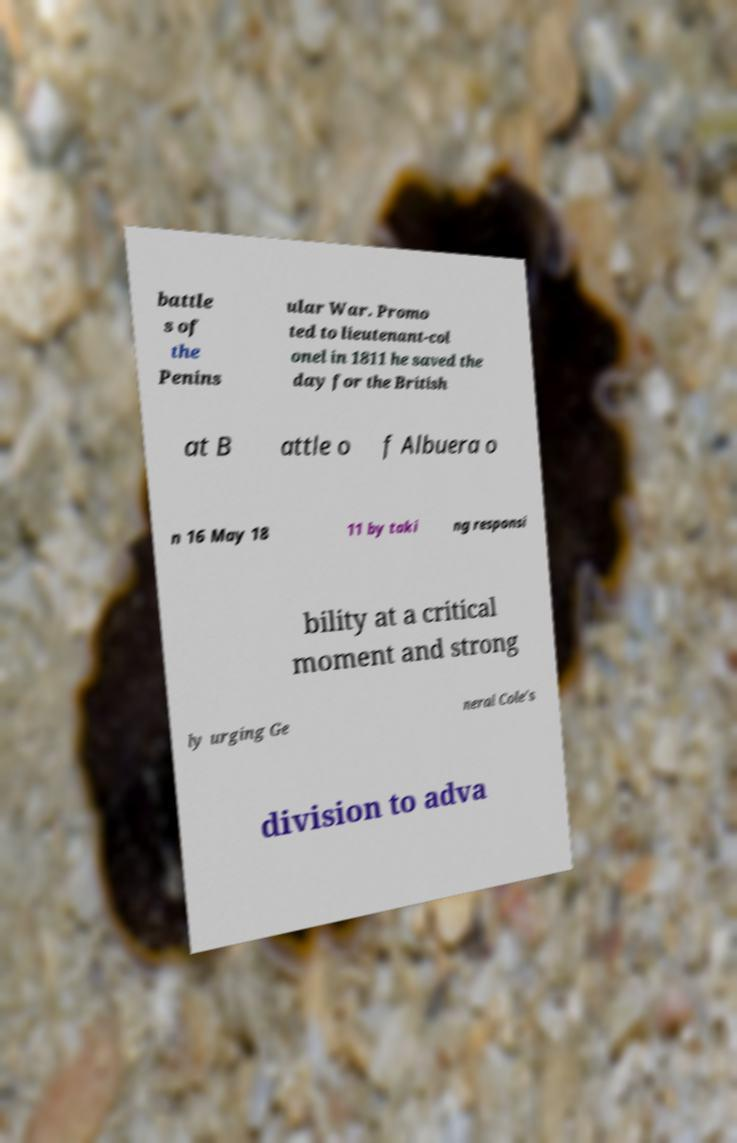I need the written content from this picture converted into text. Can you do that? battle s of the Penins ular War. Promo ted to lieutenant-col onel in 1811 he saved the day for the British at B attle o f Albuera o n 16 May 18 11 by taki ng responsi bility at a critical moment and strong ly urging Ge neral Cole's division to adva 